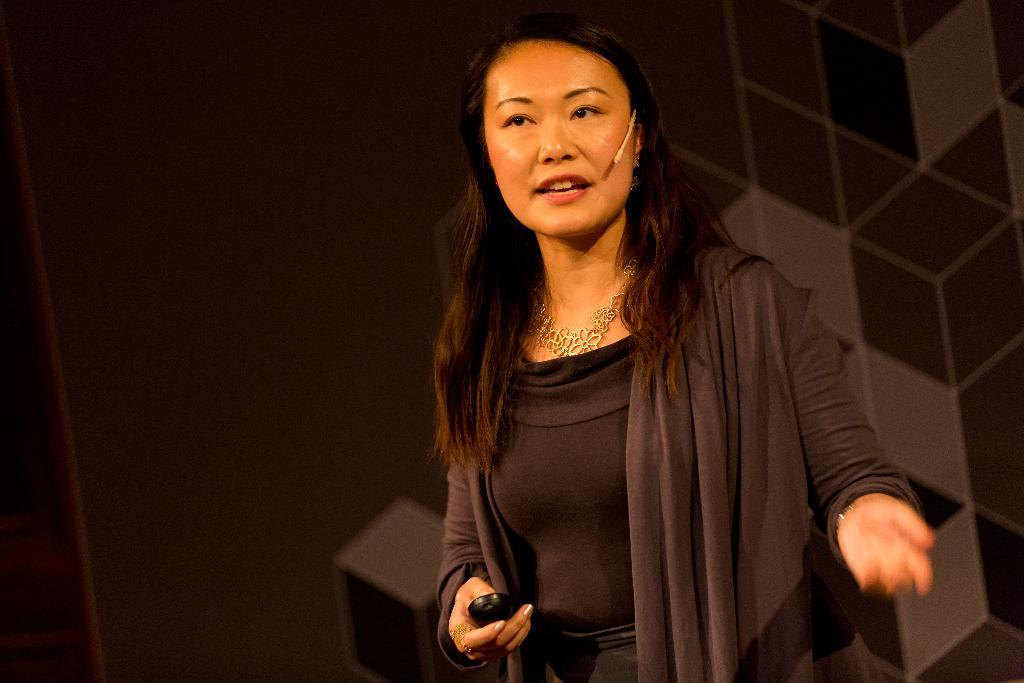Who is the main subject in the image? There is a woman in the image. What is the woman doing in the image? The woman is standing and appears to be speaking. What is the woman holding in her hand? The woman is holding a remote-like object in her hand. What can be observed about the background of the image? The background of the image is dark. Can you tell me how many basketballs are visible in the image? There are no basketballs present in the image. What type of finger is the woman using to speak in the image? The woman is speaking with her mouth, not her fingers, and there are no fingers visible in the image. 